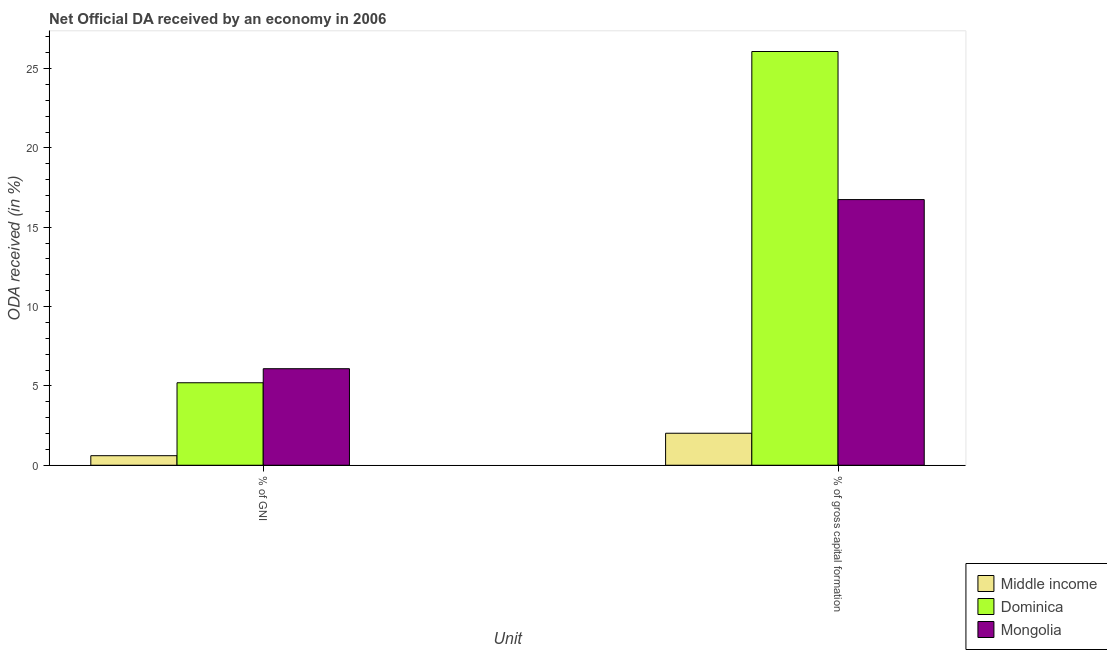How many groups of bars are there?
Your response must be concise. 2. How many bars are there on the 2nd tick from the left?
Offer a very short reply. 3. How many bars are there on the 2nd tick from the right?
Make the answer very short. 3. What is the label of the 1st group of bars from the left?
Offer a terse response. % of GNI. What is the oda received as percentage of gni in Dominica?
Offer a terse response. 5.2. Across all countries, what is the maximum oda received as percentage of gross capital formation?
Make the answer very short. 26.08. Across all countries, what is the minimum oda received as percentage of gross capital formation?
Make the answer very short. 2.02. In which country was the oda received as percentage of gross capital formation maximum?
Provide a short and direct response. Dominica. In which country was the oda received as percentage of gross capital formation minimum?
Your response must be concise. Middle income. What is the total oda received as percentage of gni in the graph?
Make the answer very short. 11.89. What is the difference between the oda received as percentage of gni in Dominica and that in Mongolia?
Provide a short and direct response. -0.89. What is the difference between the oda received as percentage of gross capital formation in Mongolia and the oda received as percentage of gni in Dominica?
Keep it short and to the point. 11.54. What is the average oda received as percentage of gross capital formation per country?
Provide a succinct answer. 14.95. What is the difference between the oda received as percentage of gni and oda received as percentage of gross capital formation in Middle income?
Provide a succinct answer. -1.41. What is the ratio of the oda received as percentage of gni in Dominica to that in Middle income?
Give a very brief answer. 8.64. Is the oda received as percentage of gross capital formation in Mongolia less than that in Middle income?
Keep it short and to the point. No. In how many countries, is the oda received as percentage of gni greater than the average oda received as percentage of gni taken over all countries?
Give a very brief answer. 2. What does the 3rd bar from the left in % of gross capital formation represents?
Ensure brevity in your answer.  Mongolia. What does the 3rd bar from the right in % of GNI represents?
Keep it short and to the point. Middle income. How many bars are there?
Provide a short and direct response. 6. Are all the bars in the graph horizontal?
Provide a succinct answer. No. How many countries are there in the graph?
Keep it short and to the point. 3. What is the difference between two consecutive major ticks on the Y-axis?
Offer a very short reply. 5. Does the graph contain any zero values?
Ensure brevity in your answer.  No. Does the graph contain grids?
Offer a terse response. No. What is the title of the graph?
Your answer should be very brief. Net Official DA received by an economy in 2006. Does "Palau" appear as one of the legend labels in the graph?
Your answer should be compact. No. What is the label or title of the X-axis?
Keep it short and to the point. Unit. What is the label or title of the Y-axis?
Your response must be concise. ODA received (in %). What is the ODA received (in %) in Middle income in % of GNI?
Give a very brief answer. 0.6. What is the ODA received (in %) in Dominica in % of GNI?
Make the answer very short. 5.2. What is the ODA received (in %) in Mongolia in % of GNI?
Provide a short and direct response. 6.08. What is the ODA received (in %) of Middle income in % of gross capital formation?
Ensure brevity in your answer.  2.02. What is the ODA received (in %) in Dominica in % of gross capital formation?
Your response must be concise. 26.08. What is the ODA received (in %) in Mongolia in % of gross capital formation?
Your response must be concise. 16.74. Across all Unit, what is the maximum ODA received (in %) in Middle income?
Ensure brevity in your answer.  2.02. Across all Unit, what is the maximum ODA received (in %) of Dominica?
Ensure brevity in your answer.  26.08. Across all Unit, what is the maximum ODA received (in %) of Mongolia?
Keep it short and to the point. 16.74. Across all Unit, what is the minimum ODA received (in %) of Middle income?
Make the answer very short. 0.6. Across all Unit, what is the minimum ODA received (in %) of Dominica?
Keep it short and to the point. 5.2. Across all Unit, what is the minimum ODA received (in %) in Mongolia?
Your answer should be compact. 6.08. What is the total ODA received (in %) in Middle income in the graph?
Offer a terse response. 2.62. What is the total ODA received (in %) in Dominica in the graph?
Your response must be concise. 31.28. What is the total ODA received (in %) in Mongolia in the graph?
Make the answer very short. 22.83. What is the difference between the ODA received (in %) of Middle income in % of GNI and that in % of gross capital formation?
Give a very brief answer. -1.41. What is the difference between the ODA received (in %) of Dominica in % of GNI and that in % of gross capital formation?
Ensure brevity in your answer.  -20.88. What is the difference between the ODA received (in %) in Mongolia in % of GNI and that in % of gross capital formation?
Make the answer very short. -10.66. What is the difference between the ODA received (in %) in Middle income in % of GNI and the ODA received (in %) in Dominica in % of gross capital formation?
Make the answer very short. -25.48. What is the difference between the ODA received (in %) of Middle income in % of GNI and the ODA received (in %) of Mongolia in % of gross capital formation?
Provide a succinct answer. -16.14. What is the difference between the ODA received (in %) in Dominica in % of GNI and the ODA received (in %) in Mongolia in % of gross capital formation?
Make the answer very short. -11.54. What is the average ODA received (in %) in Middle income per Unit?
Offer a terse response. 1.31. What is the average ODA received (in %) in Dominica per Unit?
Ensure brevity in your answer.  15.64. What is the average ODA received (in %) in Mongolia per Unit?
Offer a very short reply. 11.41. What is the difference between the ODA received (in %) of Middle income and ODA received (in %) of Dominica in % of GNI?
Ensure brevity in your answer.  -4.6. What is the difference between the ODA received (in %) in Middle income and ODA received (in %) in Mongolia in % of GNI?
Provide a succinct answer. -5.48. What is the difference between the ODA received (in %) of Dominica and ODA received (in %) of Mongolia in % of GNI?
Your response must be concise. -0.89. What is the difference between the ODA received (in %) of Middle income and ODA received (in %) of Dominica in % of gross capital formation?
Make the answer very short. -24.06. What is the difference between the ODA received (in %) of Middle income and ODA received (in %) of Mongolia in % of gross capital formation?
Make the answer very short. -14.73. What is the difference between the ODA received (in %) in Dominica and ODA received (in %) in Mongolia in % of gross capital formation?
Provide a succinct answer. 9.33. What is the ratio of the ODA received (in %) in Middle income in % of GNI to that in % of gross capital formation?
Your answer should be compact. 0.3. What is the ratio of the ODA received (in %) in Dominica in % of GNI to that in % of gross capital formation?
Offer a very short reply. 0.2. What is the ratio of the ODA received (in %) in Mongolia in % of GNI to that in % of gross capital formation?
Provide a short and direct response. 0.36. What is the difference between the highest and the second highest ODA received (in %) in Middle income?
Offer a very short reply. 1.41. What is the difference between the highest and the second highest ODA received (in %) of Dominica?
Provide a short and direct response. 20.88. What is the difference between the highest and the second highest ODA received (in %) of Mongolia?
Provide a succinct answer. 10.66. What is the difference between the highest and the lowest ODA received (in %) of Middle income?
Your answer should be very brief. 1.41. What is the difference between the highest and the lowest ODA received (in %) of Dominica?
Your response must be concise. 20.88. What is the difference between the highest and the lowest ODA received (in %) in Mongolia?
Keep it short and to the point. 10.66. 